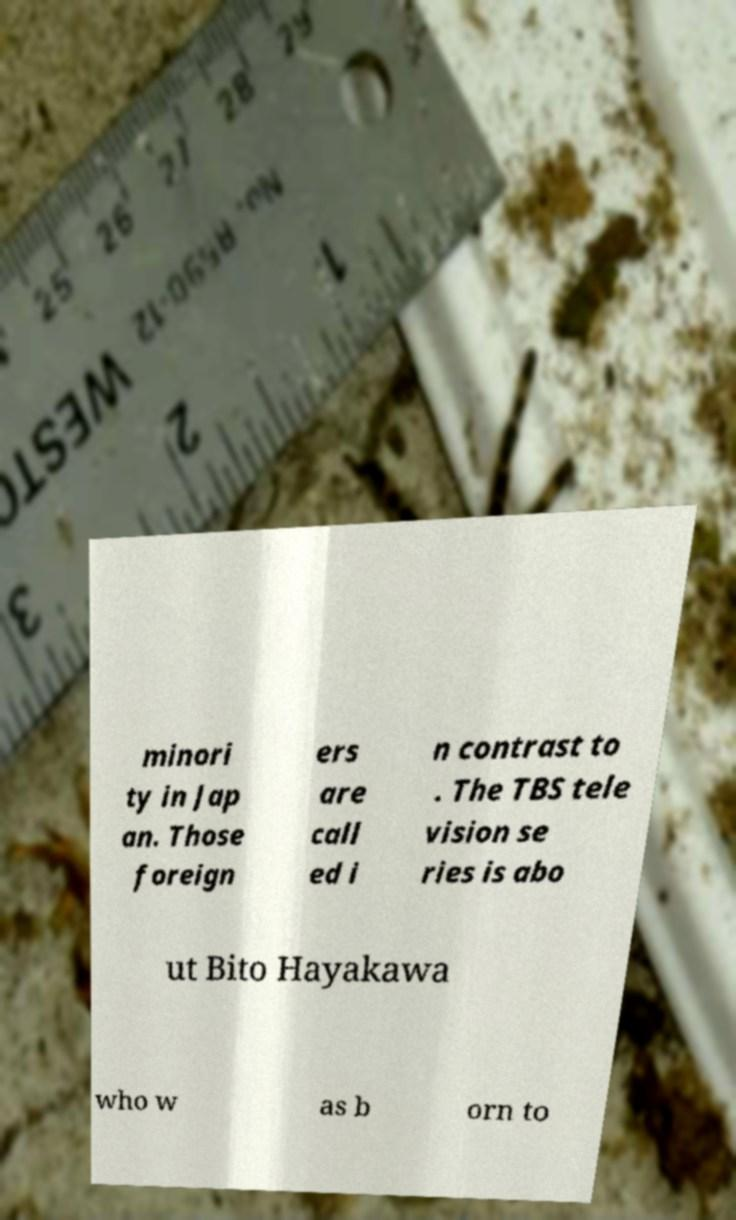Can you read and provide the text displayed in the image?This photo seems to have some interesting text. Can you extract and type it out for me? minori ty in Jap an. Those foreign ers are call ed i n contrast to . The TBS tele vision se ries is abo ut Bito Hayakawa who w as b orn to 